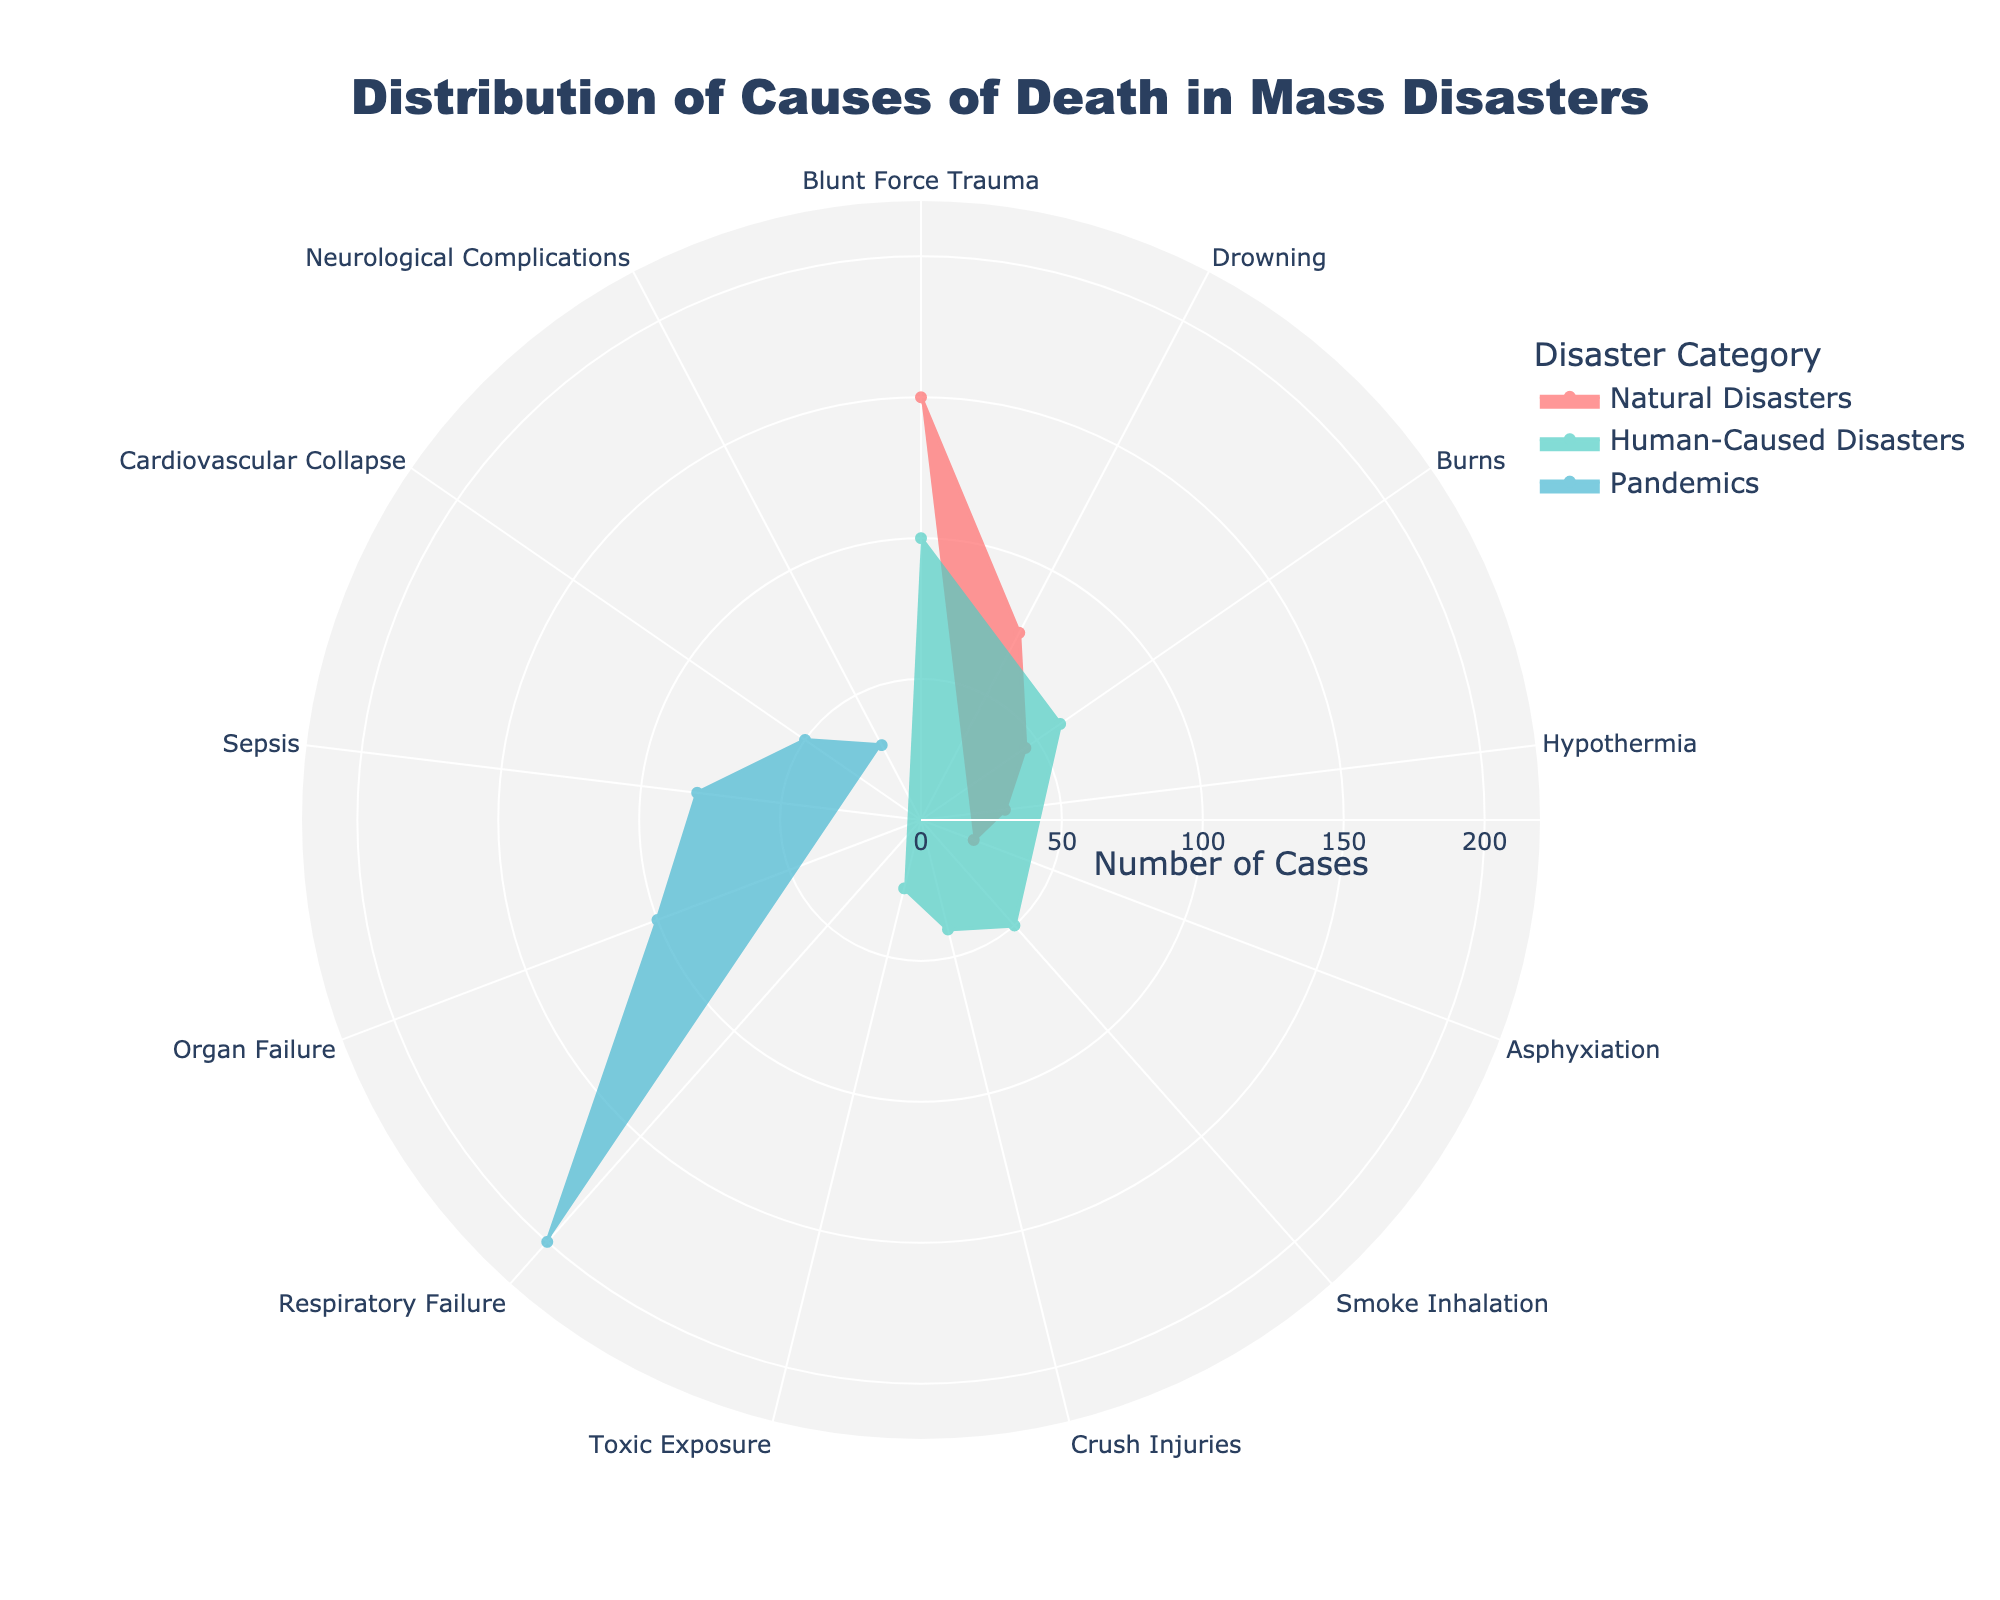What is the title of the chart? The title of the chart is usually displayed prominently at the top and is meant to give a brief description of the content of the chart. By visually inspecting the chart's top section, the title can be found.
Answer: Distribution of Causes of Death in Mass Disasters Which disaster category has the highest number of cases for a single cause of death? By examining the chart, you can identify the disaster category with the largest radial extent in one of its sectors, corresponding to the highest number of cases for a single cause of death.
Answer: Pandemics (Respiratory Failure) Compare the number of cases of Blunt Force Trauma between Natural Disasters and Human-Caused Disasters. Locate the sectors labeled "Blunt Force Trauma" for both Natural Disasters and Human-Caused Disasters on the chart. Note the radial length or numerical value associated with each. Subtract the smaller value from the larger value to find the difference.
Answer: Natural Disasters: 150, Human-Caused Disasters: 100, Difference: 50 Which cause of death has the fewest total cases across all categories? Sum the number of cases for each cause of death across all disaster categories by visually comparing the radial lengths. Identify the cause with the smallest total sum.
Answer: Asphyxiation (20 cases) What is the combined number of cases for Burns across all disaster categories? Find and sum the radial extents or numerical values for the "Burns" cause of death in both Natural Disasters and Human-Caused Disasters categories.
Answer: Natural Disasters: 45, Human-Caused Disasters: 60, Total: 105 Which disaster category shares similar number of cases for two different causes of death? Look for categories where two sectors have approximately the same radial length. This will indicate similar numbers of cases for two different causes of death within that category.
Answer: Pandemics: Cardiovascular Collapse (50) and Neurological Complications (30) What is the least common cause of death in Human-Caused Disasters? For the Human-Caused Disasters category, identify the sector with the smallest radial extent. This will represent the least common cause of death within that category.
Answer: Toxic Exposure (25 cases) How does the number of sepsis cases in pandemics compare to the sum of all drowning cases in natural disasters? Check the radial length or numerical value for sepsis in pandemics, then compare it to the total for drowning (noting there's only one data point for drowning, simplifying direct comparison).
Answer: Pandemics (Sepsis): 80, Natural Disasters (Drowning): 75; Sepsis is higher by 5 cases Is the number of blunt force trauma cases in natural disasters greater than the total number of all causes in human-caused disasters? Sum the number of cases for all causes in the Human-Caused Disasters category, then compare this sum to the number of blunt force trauma cases in the Natural Disasters category.
Answer: Blunt Force Trauma in Natural Disasters: 150, Total Human-Caused Disasters: 275; 150 is not greater Identify the cause of death with the maximum number of cases. Scan for the sector with the largest radial extent across all categories. The label corresponding to this sector indicates the cause of death with the maximum number of cases.
Answer: Respiratory Failure (200 cases) 